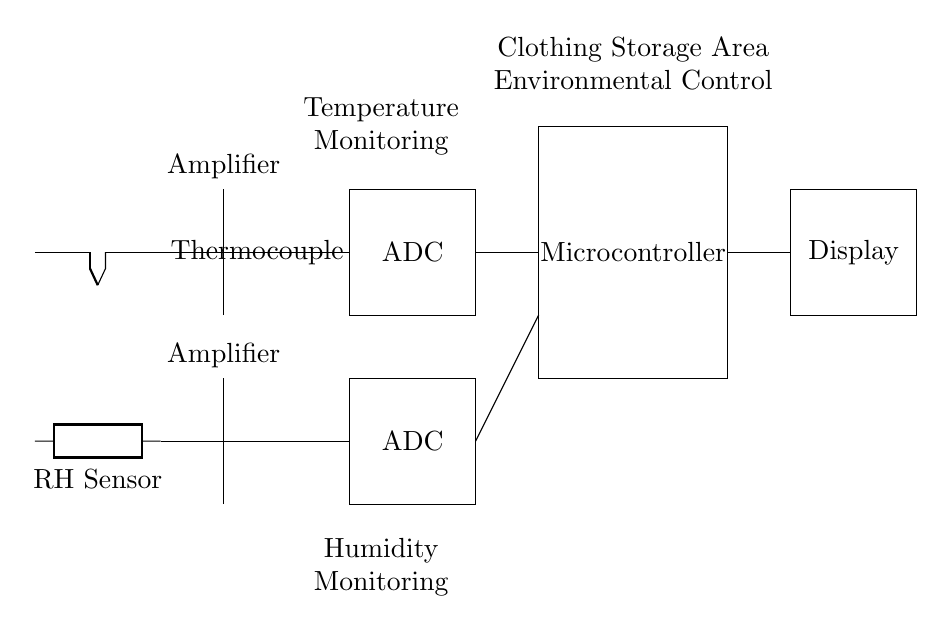What type of sensors are used in this circuit? The circuit includes a thermocouple for temperature measurement and an RH sensor for humidity measurement, as indicated in the labeled components.
Answer: Thermocouple and RH sensor What is the role of the amplifier in this circuit? The amplifiers are used after the thermocouple and RH sensor to amplify the small signals generated by these sensors before they are sent to the ADC for digitization.
Answer: Signal amplification How many amplifiers are present in the circuit? There are two amplifiers; one is connected to the thermocouple and the other to the humidity sensor.
Answer: Two What does the ADC do in this circuit? The ADC (Analog-to-Digital Converter) converts the analog signals from the amplifiers into digital signals for processing by the microcontroller, allowing for data manipulation and display.
Answer: Convert analog to digital What is the function of the microcontroller in this setup? The microcontroller processes the digital signals from the ADC, making decisions based on the temperature and humidity data, and controlling the display output.
Answer: Process data Which component is responsible for displaying the temperature and humidity readings? The display component shows the readings that have been processed by the microcontroller, typically representing the current environmental conditions in the storage area.
Answer: Display 